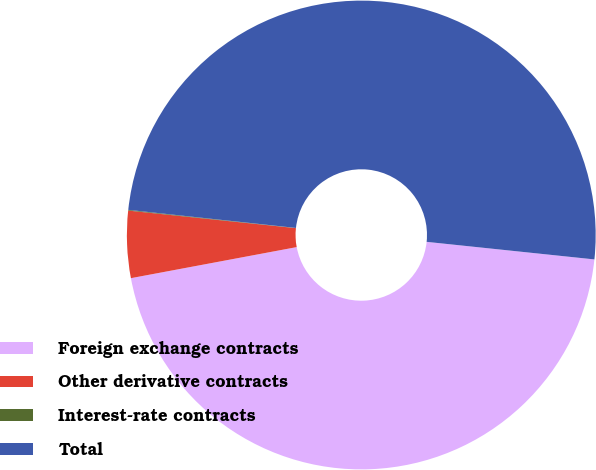Convert chart. <chart><loc_0><loc_0><loc_500><loc_500><pie_chart><fcel>Foreign exchange contracts<fcel>Other derivative contracts<fcel>Interest-rate contracts<fcel>Total<nl><fcel>45.39%<fcel>4.61%<fcel>0.05%<fcel>49.95%<nl></chart> 